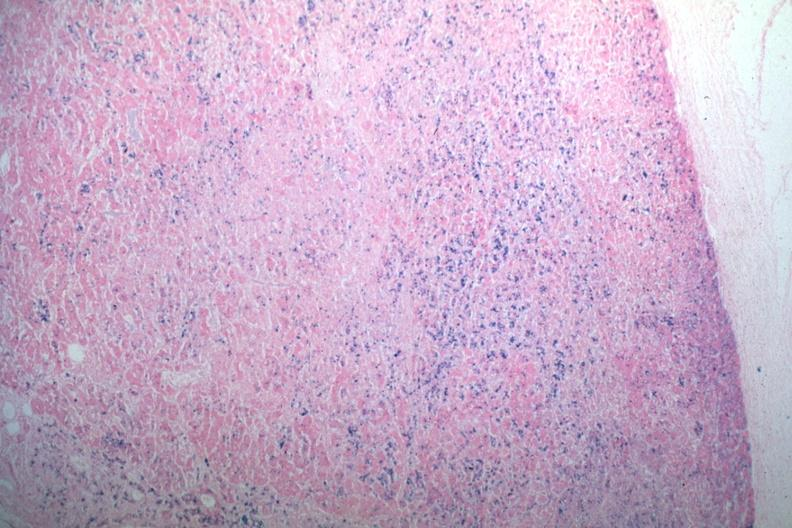what stain abundant iron?
Answer the question using a single word or phrase. Iron 